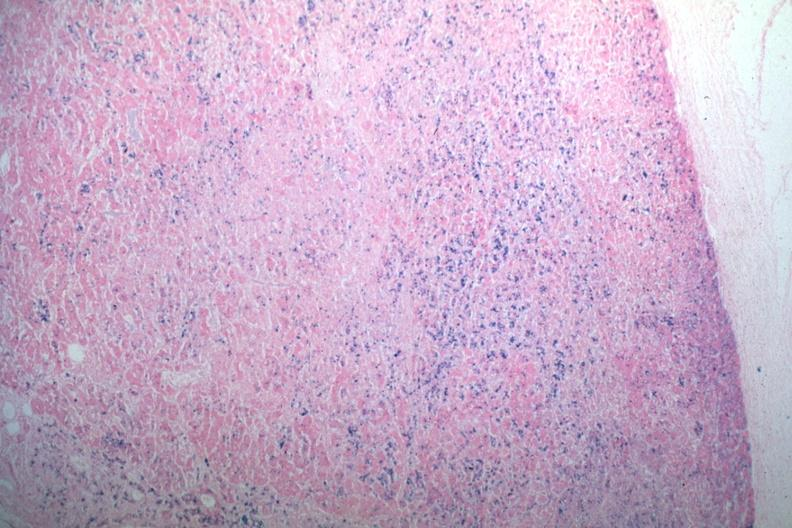what stain abundant iron?
Answer the question using a single word or phrase. Iron 